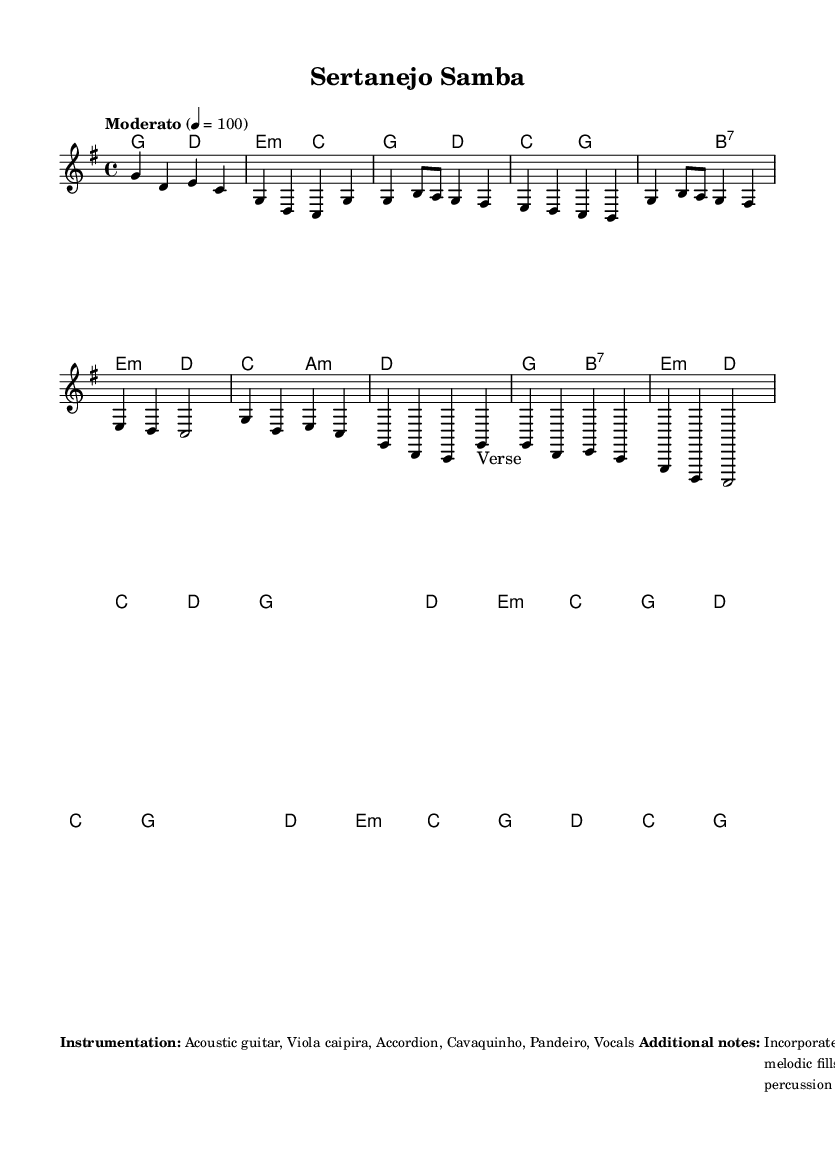What is the key signature of this music? The key signature indicates G major, which contains one sharp (F#). This can be identified by looking at the key signature at the beginning of the staff.
Answer: G major What is the time signature of the piece? The time signature is 4/4, which can be seen at the beginning of the score. This means there are four beats in each measure and the quarter note gets one beat.
Answer: 4/4 What is the tempo marking for the piece? The tempo marking is "Moderato," with a metronome indication of quarter note = 100 beats per minute. This is specified with the tempo text above the staff.
Answer: Moderato How many measures are in the chorus section? The chorus section includes four measures as shown by the music notes and rests in that specific section of the melody and the corresponding chord progression.
Answer: 4 measures What instrumentation is used in this piece? The instrumentation consists of acoustic guitar, viola caipira, accordion, cavaquinho, pandeiro, and vocals, listed in the markup section at the bottom of the score.
Answer: Acoustic guitar, Viola caipira, Accordion, Cavaquinho, Pandeiro, Vocals What style of vocal harmonies is incorporated in the song? The song features country-style vocal harmonies, as mentioned in the additional notes. These harmonies are typical of country music and complement the Brazilian-inspired melodies found in the piece.
Answer: Country-style 